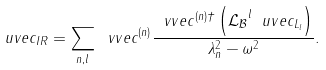<formula> <loc_0><loc_0><loc_500><loc_500>\ u v e c _ { I R } = \sum _ { n , l } \ v v e c ^ { ( n ) } \frac { \ v v e c ^ { ( n ) \dagger } \left ( \mathcal { L _ { B } } ^ { l } \ u v e c _ { L _ { l } } \right ) } { \lambda _ { n } ^ { 2 } - \omega ^ { 2 } } .</formula> 